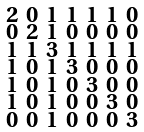Convert formula to latex. <formula><loc_0><loc_0><loc_500><loc_500>\begin{smallmatrix} 2 & 0 & 1 & 1 & 1 & 1 & 0 \\ 0 & 2 & 1 & 0 & 0 & 0 & 0 \\ 1 & 1 & 3 & 1 & 1 & 1 & 1 \\ 1 & 0 & 1 & 3 & 0 & 0 & 0 \\ 1 & 0 & 1 & 0 & 3 & 0 & 0 \\ 1 & 0 & 1 & 0 & 0 & 3 & 0 \\ 0 & 0 & 1 & 0 & 0 & 0 & 3 \end{smallmatrix}</formula> 